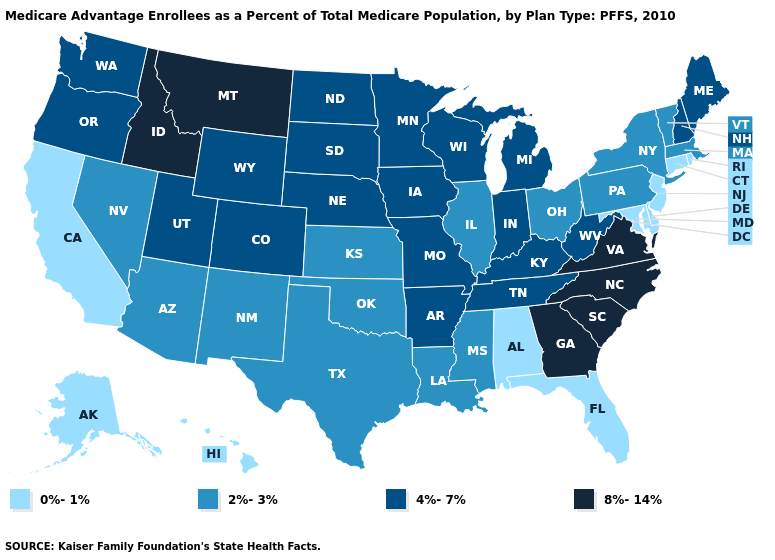What is the value of Mississippi?
Be succinct. 2%-3%. What is the lowest value in the West?
Quick response, please. 0%-1%. Name the states that have a value in the range 2%-3%?
Give a very brief answer. Arizona, Illinois, Kansas, Louisiana, Massachusetts, Mississippi, New Mexico, Nevada, New York, Ohio, Oklahoma, Pennsylvania, Texas, Vermont. Name the states that have a value in the range 0%-1%?
Give a very brief answer. Alaska, Alabama, California, Connecticut, Delaware, Florida, Hawaii, Maryland, New Jersey, Rhode Island. What is the value of Arizona?
Concise answer only. 2%-3%. Among the states that border Ohio , which have the lowest value?
Be succinct. Pennsylvania. What is the highest value in states that border North Dakota?
Short answer required. 8%-14%. What is the value of Nevada?
Quick response, please. 2%-3%. Is the legend a continuous bar?
Answer briefly. No. What is the highest value in states that border Illinois?
Answer briefly. 4%-7%. Name the states that have a value in the range 0%-1%?
Answer briefly. Alaska, Alabama, California, Connecticut, Delaware, Florida, Hawaii, Maryland, New Jersey, Rhode Island. What is the value of Indiana?
Concise answer only. 4%-7%. What is the value of Oklahoma?
Quick response, please. 2%-3%. What is the highest value in the Northeast ?
Quick response, please. 4%-7%. Does Wisconsin have the highest value in the MidWest?
Answer briefly. Yes. 